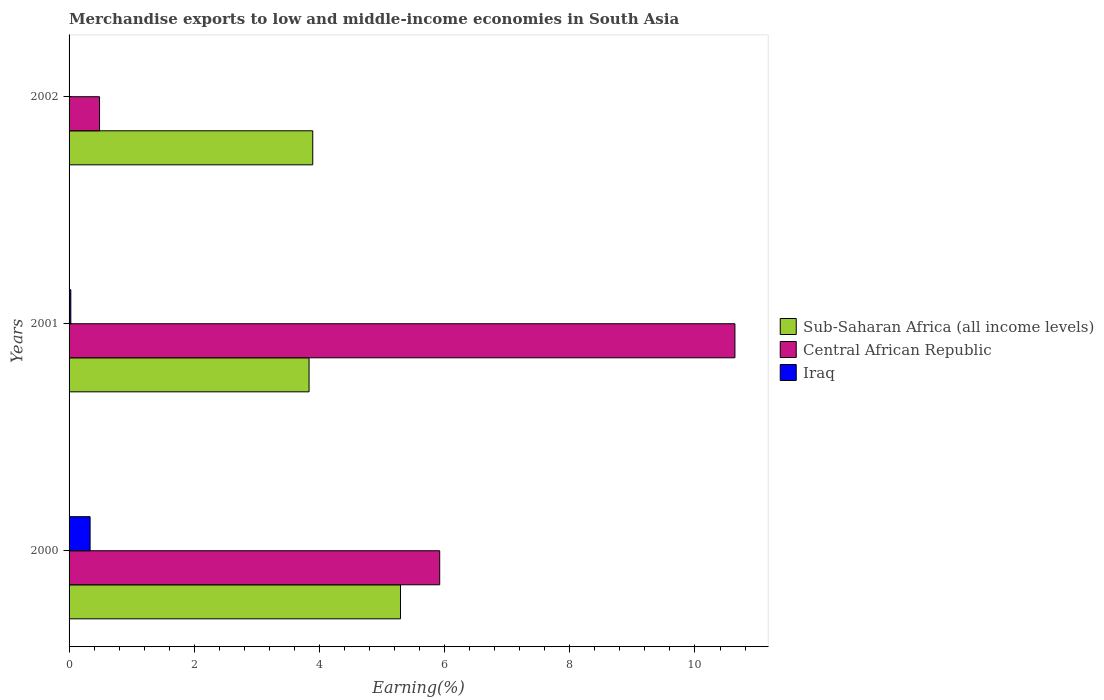How many different coloured bars are there?
Provide a short and direct response. 3. How many groups of bars are there?
Provide a short and direct response. 3. Are the number of bars per tick equal to the number of legend labels?
Your response must be concise. Yes. Are the number of bars on each tick of the Y-axis equal?
Provide a succinct answer. Yes. How many bars are there on the 1st tick from the bottom?
Offer a terse response. 3. In how many cases, is the number of bars for a given year not equal to the number of legend labels?
Provide a short and direct response. 0. What is the percentage of amount earned from merchandise exports in Central African Republic in 2000?
Provide a short and direct response. 5.92. Across all years, what is the maximum percentage of amount earned from merchandise exports in Iraq?
Provide a succinct answer. 0.34. Across all years, what is the minimum percentage of amount earned from merchandise exports in Iraq?
Your response must be concise. 0. In which year was the percentage of amount earned from merchandise exports in Iraq maximum?
Your answer should be very brief. 2000. What is the total percentage of amount earned from merchandise exports in Iraq in the graph?
Keep it short and to the point. 0.37. What is the difference between the percentage of amount earned from merchandise exports in Central African Republic in 2000 and that in 2001?
Provide a short and direct response. -4.72. What is the difference between the percentage of amount earned from merchandise exports in Iraq in 2001 and the percentage of amount earned from merchandise exports in Central African Republic in 2002?
Give a very brief answer. -0.46. What is the average percentage of amount earned from merchandise exports in Central African Republic per year?
Ensure brevity in your answer.  5.68. In the year 2001, what is the difference between the percentage of amount earned from merchandise exports in Central African Republic and percentage of amount earned from merchandise exports in Sub-Saharan Africa (all income levels)?
Your answer should be compact. 6.8. What is the ratio of the percentage of amount earned from merchandise exports in Central African Republic in 2000 to that in 2001?
Your answer should be compact. 0.56. Is the percentage of amount earned from merchandise exports in Iraq in 2000 less than that in 2002?
Provide a short and direct response. No. Is the difference between the percentage of amount earned from merchandise exports in Central African Republic in 2000 and 2002 greater than the difference between the percentage of amount earned from merchandise exports in Sub-Saharan Africa (all income levels) in 2000 and 2002?
Provide a short and direct response. Yes. What is the difference between the highest and the second highest percentage of amount earned from merchandise exports in Iraq?
Your answer should be compact. 0.31. What is the difference between the highest and the lowest percentage of amount earned from merchandise exports in Iraq?
Make the answer very short. 0.33. What does the 1st bar from the top in 2001 represents?
Give a very brief answer. Iraq. What does the 3rd bar from the bottom in 2001 represents?
Provide a succinct answer. Iraq. Are all the bars in the graph horizontal?
Offer a very short reply. Yes. How many years are there in the graph?
Make the answer very short. 3. What is the difference between two consecutive major ticks on the X-axis?
Ensure brevity in your answer.  2. Does the graph contain any zero values?
Keep it short and to the point. No. Where does the legend appear in the graph?
Your response must be concise. Center right. What is the title of the graph?
Your response must be concise. Merchandise exports to low and middle-income economies in South Asia. What is the label or title of the X-axis?
Ensure brevity in your answer.  Earning(%). What is the Earning(%) of Sub-Saharan Africa (all income levels) in 2000?
Provide a succinct answer. 5.3. What is the Earning(%) of Central African Republic in 2000?
Ensure brevity in your answer.  5.92. What is the Earning(%) in Iraq in 2000?
Offer a very short reply. 0.34. What is the Earning(%) of Sub-Saharan Africa (all income levels) in 2001?
Make the answer very short. 3.83. What is the Earning(%) of Central African Republic in 2001?
Make the answer very short. 10.64. What is the Earning(%) in Iraq in 2001?
Make the answer very short. 0.03. What is the Earning(%) of Sub-Saharan Africa (all income levels) in 2002?
Make the answer very short. 3.89. What is the Earning(%) in Central African Republic in 2002?
Give a very brief answer. 0.49. What is the Earning(%) of Iraq in 2002?
Give a very brief answer. 0. Across all years, what is the maximum Earning(%) of Sub-Saharan Africa (all income levels)?
Provide a succinct answer. 5.3. Across all years, what is the maximum Earning(%) in Central African Republic?
Ensure brevity in your answer.  10.64. Across all years, what is the maximum Earning(%) in Iraq?
Your answer should be compact. 0.34. Across all years, what is the minimum Earning(%) of Sub-Saharan Africa (all income levels)?
Your answer should be very brief. 3.83. Across all years, what is the minimum Earning(%) of Central African Republic?
Give a very brief answer. 0.49. Across all years, what is the minimum Earning(%) in Iraq?
Offer a very short reply. 0. What is the total Earning(%) of Sub-Saharan Africa (all income levels) in the graph?
Keep it short and to the point. 13.02. What is the total Earning(%) in Central African Republic in the graph?
Your answer should be compact. 17.05. What is the total Earning(%) in Iraq in the graph?
Provide a short and direct response. 0.37. What is the difference between the Earning(%) in Sub-Saharan Africa (all income levels) in 2000 and that in 2001?
Keep it short and to the point. 1.46. What is the difference between the Earning(%) of Central African Republic in 2000 and that in 2001?
Your response must be concise. -4.72. What is the difference between the Earning(%) in Iraq in 2000 and that in 2001?
Your answer should be compact. 0.31. What is the difference between the Earning(%) of Sub-Saharan Africa (all income levels) in 2000 and that in 2002?
Make the answer very short. 1.4. What is the difference between the Earning(%) in Central African Republic in 2000 and that in 2002?
Offer a very short reply. 5.43. What is the difference between the Earning(%) of Iraq in 2000 and that in 2002?
Make the answer very short. 0.33. What is the difference between the Earning(%) in Sub-Saharan Africa (all income levels) in 2001 and that in 2002?
Your answer should be compact. -0.06. What is the difference between the Earning(%) of Central African Republic in 2001 and that in 2002?
Your answer should be compact. 10.15. What is the difference between the Earning(%) of Iraq in 2001 and that in 2002?
Keep it short and to the point. 0.03. What is the difference between the Earning(%) in Sub-Saharan Africa (all income levels) in 2000 and the Earning(%) in Central African Republic in 2001?
Give a very brief answer. -5.34. What is the difference between the Earning(%) of Sub-Saharan Africa (all income levels) in 2000 and the Earning(%) of Iraq in 2001?
Ensure brevity in your answer.  5.27. What is the difference between the Earning(%) of Central African Republic in 2000 and the Earning(%) of Iraq in 2001?
Provide a succinct answer. 5.89. What is the difference between the Earning(%) in Sub-Saharan Africa (all income levels) in 2000 and the Earning(%) in Central African Republic in 2002?
Your answer should be compact. 4.81. What is the difference between the Earning(%) of Sub-Saharan Africa (all income levels) in 2000 and the Earning(%) of Iraq in 2002?
Provide a succinct answer. 5.29. What is the difference between the Earning(%) of Central African Republic in 2000 and the Earning(%) of Iraq in 2002?
Provide a succinct answer. 5.92. What is the difference between the Earning(%) in Sub-Saharan Africa (all income levels) in 2001 and the Earning(%) in Central African Republic in 2002?
Offer a terse response. 3.35. What is the difference between the Earning(%) in Sub-Saharan Africa (all income levels) in 2001 and the Earning(%) in Iraq in 2002?
Make the answer very short. 3.83. What is the difference between the Earning(%) of Central African Republic in 2001 and the Earning(%) of Iraq in 2002?
Your answer should be very brief. 10.64. What is the average Earning(%) of Sub-Saharan Africa (all income levels) per year?
Your answer should be compact. 4.34. What is the average Earning(%) in Central African Republic per year?
Provide a succinct answer. 5.68. What is the average Earning(%) of Iraq per year?
Offer a terse response. 0.12. In the year 2000, what is the difference between the Earning(%) in Sub-Saharan Africa (all income levels) and Earning(%) in Central African Republic?
Your answer should be very brief. -0.63. In the year 2000, what is the difference between the Earning(%) of Sub-Saharan Africa (all income levels) and Earning(%) of Iraq?
Your answer should be very brief. 4.96. In the year 2000, what is the difference between the Earning(%) of Central African Republic and Earning(%) of Iraq?
Keep it short and to the point. 5.59. In the year 2001, what is the difference between the Earning(%) of Sub-Saharan Africa (all income levels) and Earning(%) of Central African Republic?
Provide a succinct answer. -6.8. In the year 2001, what is the difference between the Earning(%) in Sub-Saharan Africa (all income levels) and Earning(%) in Iraq?
Make the answer very short. 3.81. In the year 2001, what is the difference between the Earning(%) in Central African Republic and Earning(%) in Iraq?
Provide a succinct answer. 10.61. In the year 2002, what is the difference between the Earning(%) in Sub-Saharan Africa (all income levels) and Earning(%) in Central African Republic?
Your response must be concise. 3.41. In the year 2002, what is the difference between the Earning(%) in Sub-Saharan Africa (all income levels) and Earning(%) in Iraq?
Your answer should be very brief. 3.89. In the year 2002, what is the difference between the Earning(%) in Central African Republic and Earning(%) in Iraq?
Keep it short and to the point. 0.48. What is the ratio of the Earning(%) in Sub-Saharan Africa (all income levels) in 2000 to that in 2001?
Your answer should be compact. 1.38. What is the ratio of the Earning(%) in Central African Republic in 2000 to that in 2001?
Your response must be concise. 0.56. What is the ratio of the Earning(%) of Iraq in 2000 to that in 2001?
Provide a succinct answer. 12.04. What is the ratio of the Earning(%) in Sub-Saharan Africa (all income levels) in 2000 to that in 2002?
Offer a very short reply. 1.36. What is the ratio of the Earning(%) in Central African Republic in 2000 to that in 2002?
Keep it short and to the point. 12.16. What is the ratio of the Earning(%) of Iraq in 2000 to that in 2002?
Offer a very short reply. 170.23. What is the ratio of the Earning(%) in Sub-Saharan Africa (all income levels) in 2001 to that in 2002?
Provide a succinct answer. 0.98. What is the ratio of the Earning(%) of Central African Republic in 2001 to that in 2002?
Offer a very short reply. 21.85. What is the ratio of the Earning(%) in Iraq in 2001 to that in 2002?
Your response must be concise. 14.14. What is the difference between the highest and the second highest Earning(%) of Sub-Saharan Africa (all income levels)?
Ensure brevity in your answer.  1.4. What is the difference between the highest and the second highest Earning(%) in Central African Republic?
Your answer should be very brief. 4.72. What is the difference between the highest and the second highest Earning(%) in Iraq?
Provide a short and direct response. 0.31. What is the difference between the highest and the lowest Earning(%) in Sub-Saharan Africa (all income levels)?
Your response must be concise. 1.46. What is the difference between the highest and the lowest Earning(%) in Central African Republic?
Your answer should be very brief. 10.15. What is the difference between the highest and the lowest Earning(%) of Iraq?
Your answer should be very brief. 0.33. 